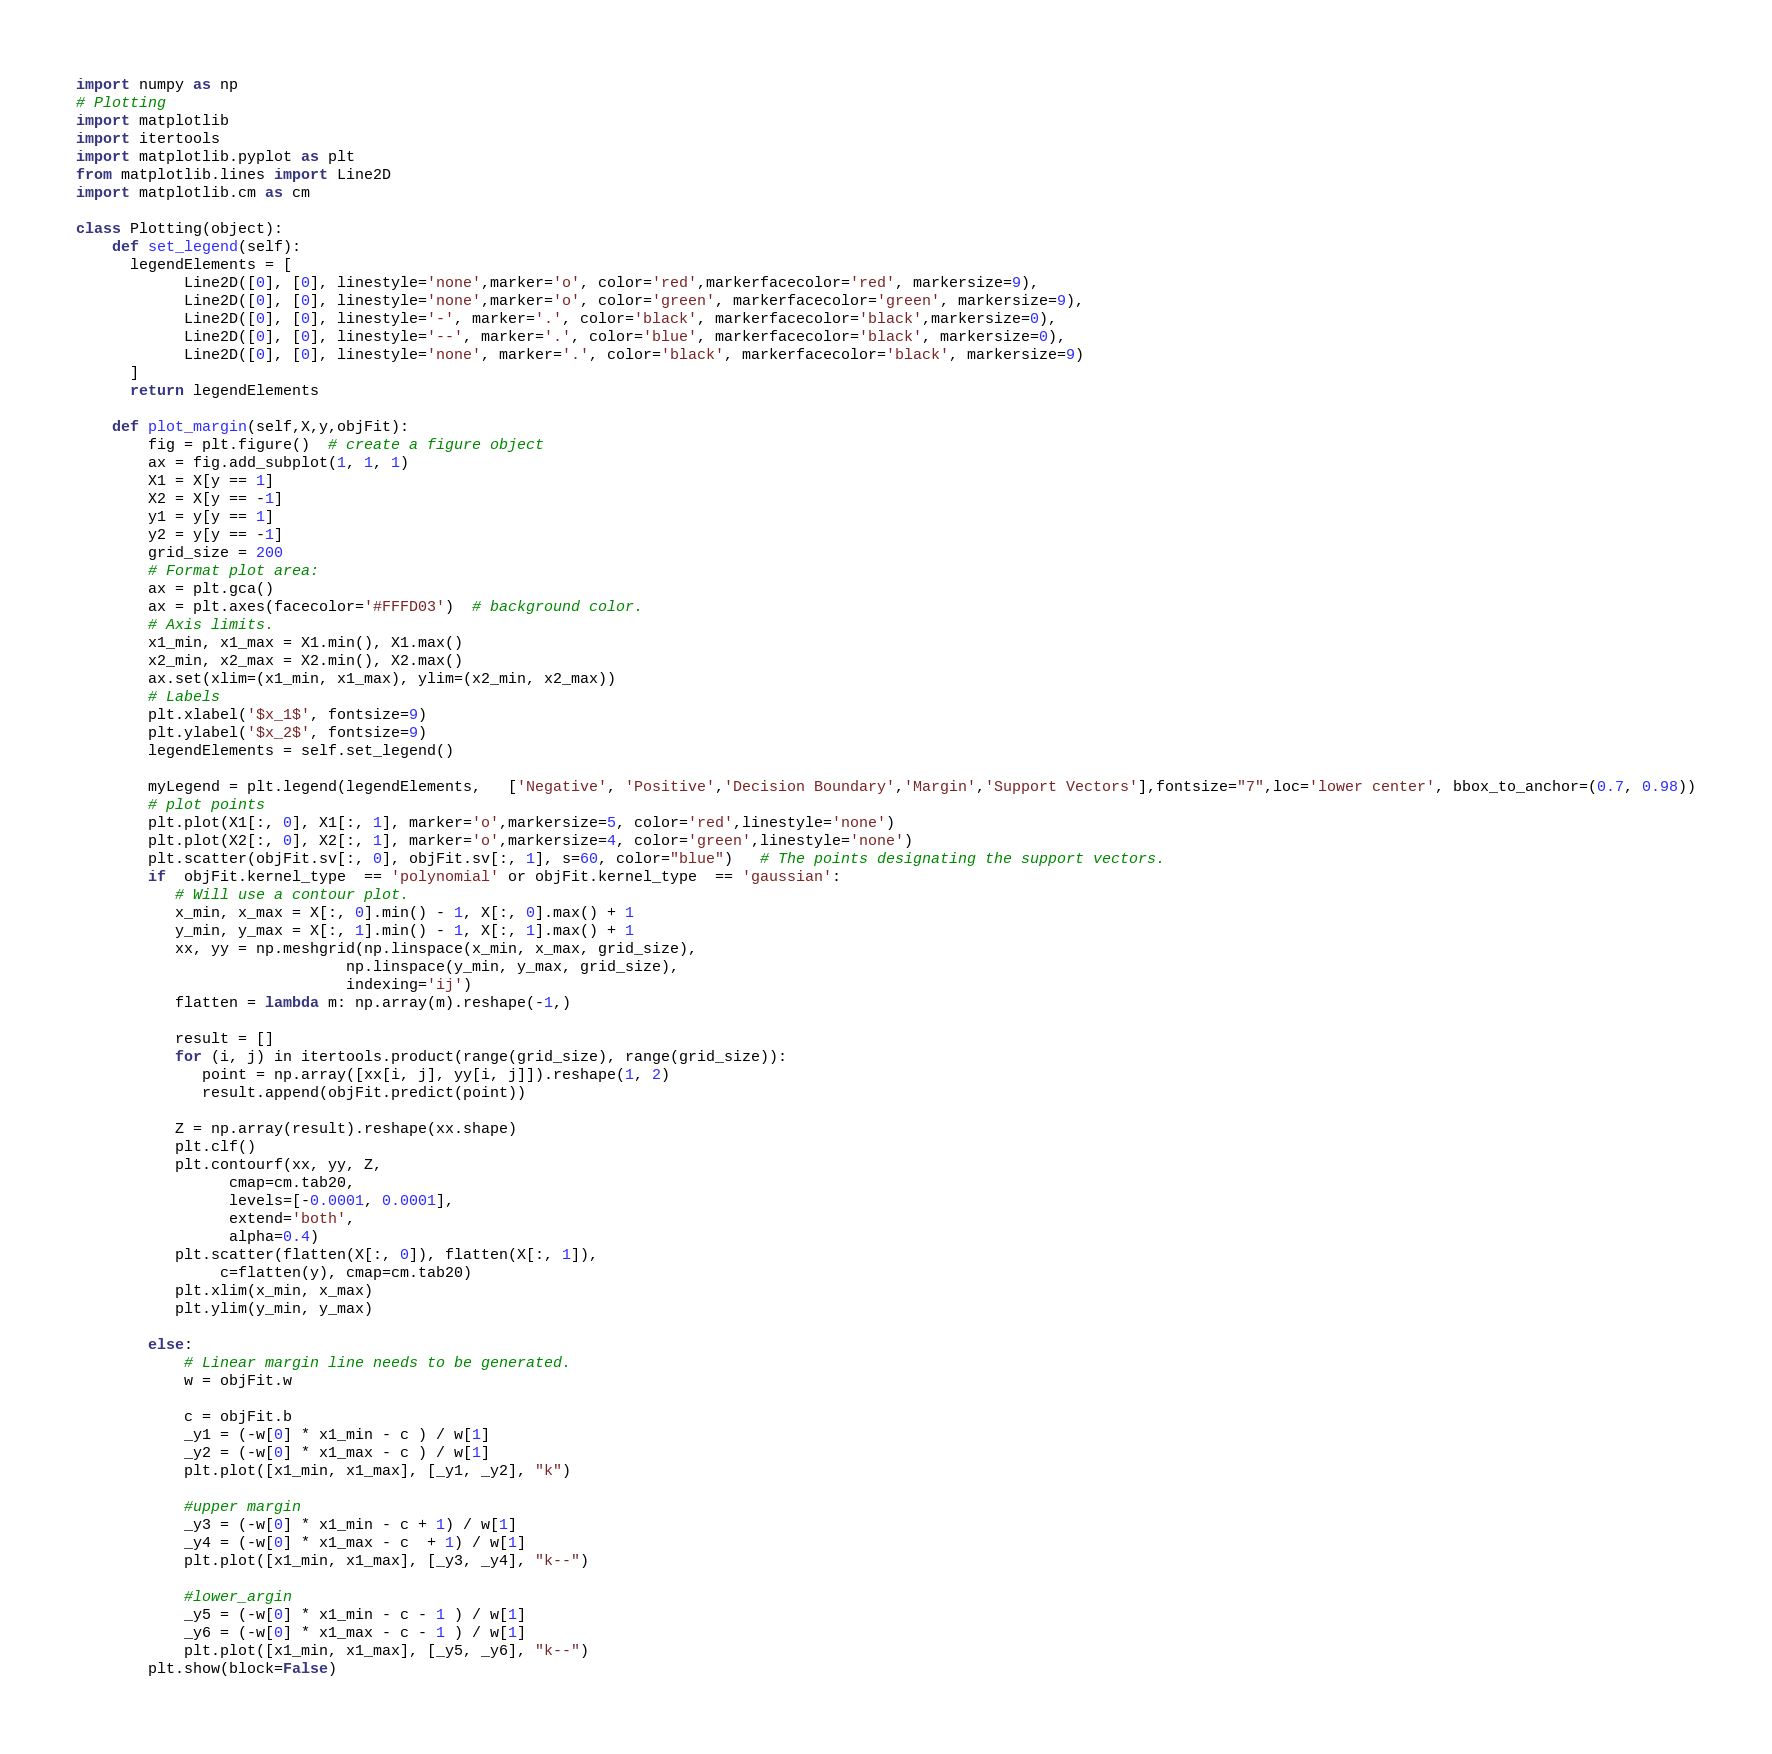Convert code to text. <code><loc_0><loc_0><loc_500><loc_500><_Python_>import numpy as np
# Plotting
import matplotlib
import itertools
import matplotlib.pyplot as plt
from matplotlib.lines import Line2D
import matplotlib.cm as cm

class Plotting(object):
    def set_legend(self):
      legendElements = [
            Line2D([0], [0], linestyle='none',marker='o', color='red',markerfacecolor='red', markersize=9),
            Line2D([0], [0], linestyle='none',marker='o', color='green', markerfacecolor='green', markersize=9),
            Line2D([0], [0], linestyle='-', marker='.', color='black', markerfacecolor='black',markersize=0),
            Line2D([0], [0], linestyle='--', marker='.', color='blue', markerfacecolor='black', markersize=0),
            Line2D([0], [0], linestyle='none', marker='.', color='black', markerfacecolor='black', markersize=9)
      ]
      return legendElements

    def plot_margin(self,X,y,objFit):
        fig = plt.figure()  # create a figure object
        ax = fig.add_subplot(1, 1, 1)
        X1 = X[y == 1]
        X2 = X[y == -1]
        y1 = y[y == 1]
        y2 = y[y == -1]
        grid_size = 200
        # Format plot area:
        ax = plt.gca()
        ax = plt.axes(facecolor='#FFFD03')  # background color.
        # Axis limits.
        x1_min, x1_max = X1.min(), X1.max()
        x2_min, x2_max = X2.min(), X2.max()
        ax.set(xlim=(x1_min, x1_max), ylim=(x2_min, x2_max))
        # Labels
        plt.xlabel('$x_1$', fontsize=9)
        plt.ylabel('$x_2$', fontsize=9)
        legendElements = self.set_legend()
        
        myLegend = plt.legend(legendElements,   ['Negative', 'Positive','Decision Boundary','Margin','Support Vectors'],fontsize="7",loc='lower center', bbox_to_anchor=(0.7, 0.98))
        # plot points
        plt.plot(X1[:, 0], X1[:, 1], marker='o',markersize=5, color='red',linestyle='none')
        plt.plot(X2[:, 0], X2[:, 1], marker='o',markersize=4, color='green',linestyle='none')
        plt.scatter(objFit.sv[:, 0], objFit.sv[:, 1], s=60, color="blue")   # The points designating the support vectors.
        if  objFit.kernel_type  == 'polynomial' or objFit.kernel_type  == 'gaussian':
           # Will use a contour plot.
           x_min, x_max = X[:, 0].min() - 1, X[:, 0].max() + 1
           y_min, y_max = X[:, 1].min() - 1, X[:, 1].max() + 1
           xx, yy = np.meshgrid(np.linspace(x_min, x_max, grid_size),
                              np.linspace(y_min, y_max, grid_size),
                              indexing='ij')
           flatten = lambda m: np.array(m).reshape(-1,)

           result = []
           for (i, j) in itertools.product(range(grid_size), range(grid_size)):
              point = np.array([xx[i, j], yy[i, j]]).reshape(1, 2)
              result.append(objFit.predict(point))

           Z = np.array(result).reshape(xx.shape)
           plt.clf()
           plt.contourf(xx, yy, Z,
                 cmap=cm.tab20,
                 levels=[-0.0001, 0.0001],
                 extend='both',
                 alpha=0.4)
           plt.scatter(flatten(X[:, 0]), flatten(X[:, 1]),
                c=flatten(y), cmap=cm.tab20)
           plt.xlim(x_min, x_max)
           plt.ylim(y_min, y_max)
          
        else:
            # Linear margin line needs to be generated.
            w = objFit.w
            
            c = objFit.b
            _y1 = (-w[0] * x1_min - c ) / w[1]
            _y2 = (-w[0] * x1_max - c ) / w[1]
            plt.plot([x1_min, x1_max], [_y1, _y2], "k")

            #upper margin
            _y3 = (-w[0] * x1_min - c + 1) / w[1]
            _y4 = (-w[0] * x1_max - c  + 1) / w[1]
            plt.plot([x1_min, x1_max], [_y3, _y4], "k--")

            #lower_argin
            _y5 = (-w[0] * x1_min - c - 1 ) / w[1]
            _y6 = (-w[0] * x1_max - c - 1 ) / w[1]
            plt.plot([x1_min, x1_max], [_y5, _y6], "k--")
        plt.show(block=False)

</code> 